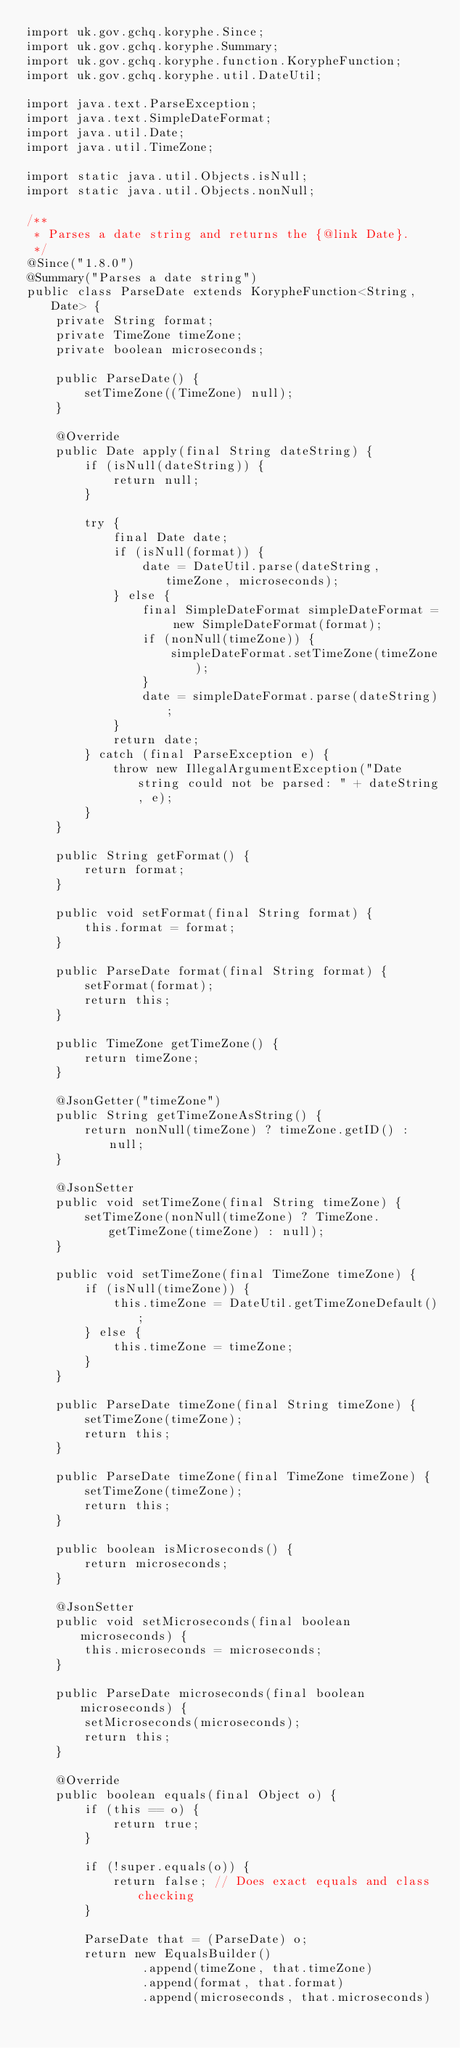Convert code to text. <code><loc_0><loc_0><loc_500><loc_500><_Java_>import uk.gov.gchq.koryphe.Since;
import uk.gov.gchq.koryphe.Summary;
import uk.gov.gchq.koryphe.function.KorypheFunction;
import uk.gov.gchq.koryphe.util.DateUtil;

import java.text.ParseException;
import java.text.SimpleDateFormat;
import java.util.Date;
import java.util.TimeZone;

import static java.util.Objects.isNull;
import static java.util.Objects.nonNull;

/**
 * Parses a date string and returns the {@link Date}.
 */
@Since("1.8.0")
@Summary("Parses a date string")
public class ParseDate extends KorypheFunction<String, Date> {
    private String format;
    private TimeZone timeZone;
    private boolean microseconds;

    public ParseDate() {
        setTimeZone((TimeZone) null);
    }

    @Override
    public Date apply(final String dateString) {
        if (isNull(dateString)) {
            return null;
        }

        try {
            final Date date;
            if (isNull(format)) {
                date = DateUtil.parse(dateString, timeZone, microseconds);
            } else {
                final SimpleDateFormat simpleDateFormat = new SimpleDateFormat(format);
                if (nonNull(timeZone)) {
                    simpleDateFormat.setTimeZone(timeZone);
                }
                date = simpleDateFormat.parse(dateString);
            }
            return date;
        } catch (final ParseException e) {
            throw new IllegalArgumentException("Date string could not be parsed: " + dateString, e);
        }
    }

    public String getFormat() {
        return format;
    }

    public void setFormat(final String format) {
        this.format = format;
    }

    public ParseDate format(final String format) {
        setFormat(format);
        return this;
    }

    public TimeZone getTimeZone() {
        return timeZone;
    }

    @JsonGetter("timeZone")
    public String getTimeZoneAsString() {
        return nonNull(timeZone) ? timeZone.getID() : null;
    }

    @JsonSetter
    public void setTimeZone(final String timeZone) {
        setTimeZone(nonNull(timeZone) ? TimeZone.getTimeZone(timeZone) : null);
    }

    public void setTimeZone(final TimeZone timeZone) {
        if (isNull(timeZone)) {
            this.timeZone = DateUtil.getTimeZoneDefault();
        } else {
            this.timeZone = timeZone;
        }
    }

    public ParseDate timeZone(final String timeZone) {
        setTimeZone(timeZone);
        return this;
    }

    public ParseDate timeZone(final TimeZone timeZone) {
        setTimeZone(timeZone);
        return this;
    }

    public boolean isMicroseconds() {
        return microseconds;
    }

    @JsonSetter
    public void setMicroseconds(final boolean microseconds) {
        this.microseconds = microseconds;
    }

    public ParseDate microseconds(final boolean microseconds) {
        setMicroseconds(microseconds);
        return this;
    }

    @Override
    public boolean equals(final Object o) {
        if (this == o) {
            return true;
        }

        if (!super.equals(o)) {
            return false; // Does exact equals and class checking
        }

        ParseDate that = (ParseDate) o;
        return new EqualsBuilder()
                .append(timeZone, that.timeZone)
                .append(format, that.format)
                .append(microseconds, that.microseconds)</code> 